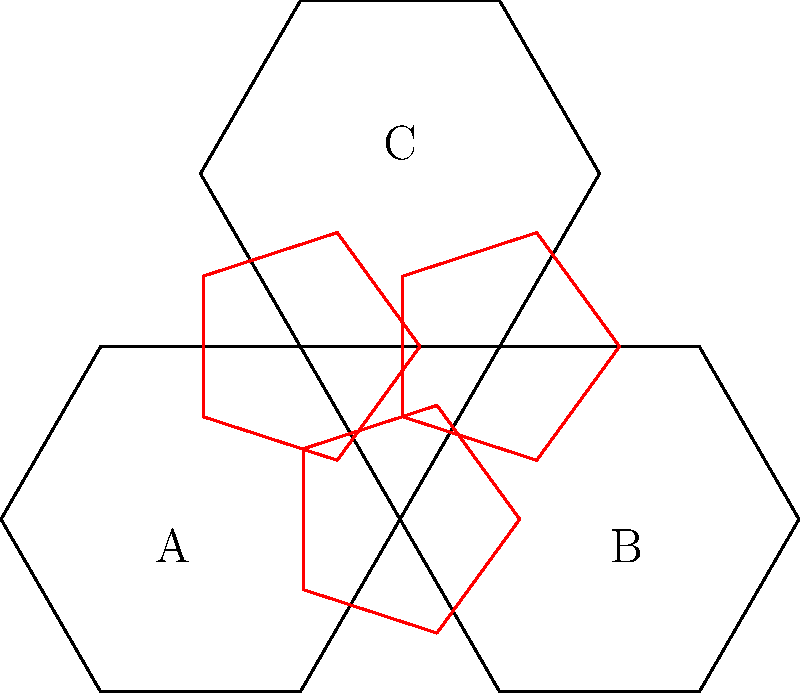Consider the partial soccer ball design shown above, composed of hexagons (black) and pentagons (red). What is the order of the rotational symmetry group for this configuration? To determine the order of the rotational symmetry group, we need to follow these steps:

1. Identify the center of rotation: The center is at the midpoint of the triangle formed by the centers of the three hexagons.

2. Determine possible rotations:
   a) 120° clockwise and counterclockwise rotations (bringing A to B, B to C, and C to A)
   b) 240° clockwise and counterclockwise rotations (bringing A to C, C to B, and B to A)
   c) 360° rotation (identity rotation)

3. Count the number of distinct rotations:
   - 0° (identity)
   - 120° clockwise
   - 240° clockwise (equivalent to 120° counterclockwise)

4. The order of the rotational symmetry group is the number of distinct rotations.

In this case, we have 3 distinct rotations that preserve the configuration.

Note: This partial design exhibits C3 symmetry, which is a cyclic group of order 3.
Answer: 3 